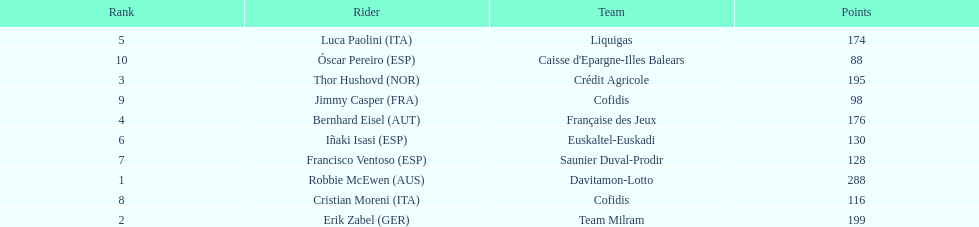How many more points did erik zabel score than franciso ventoso? 71. 